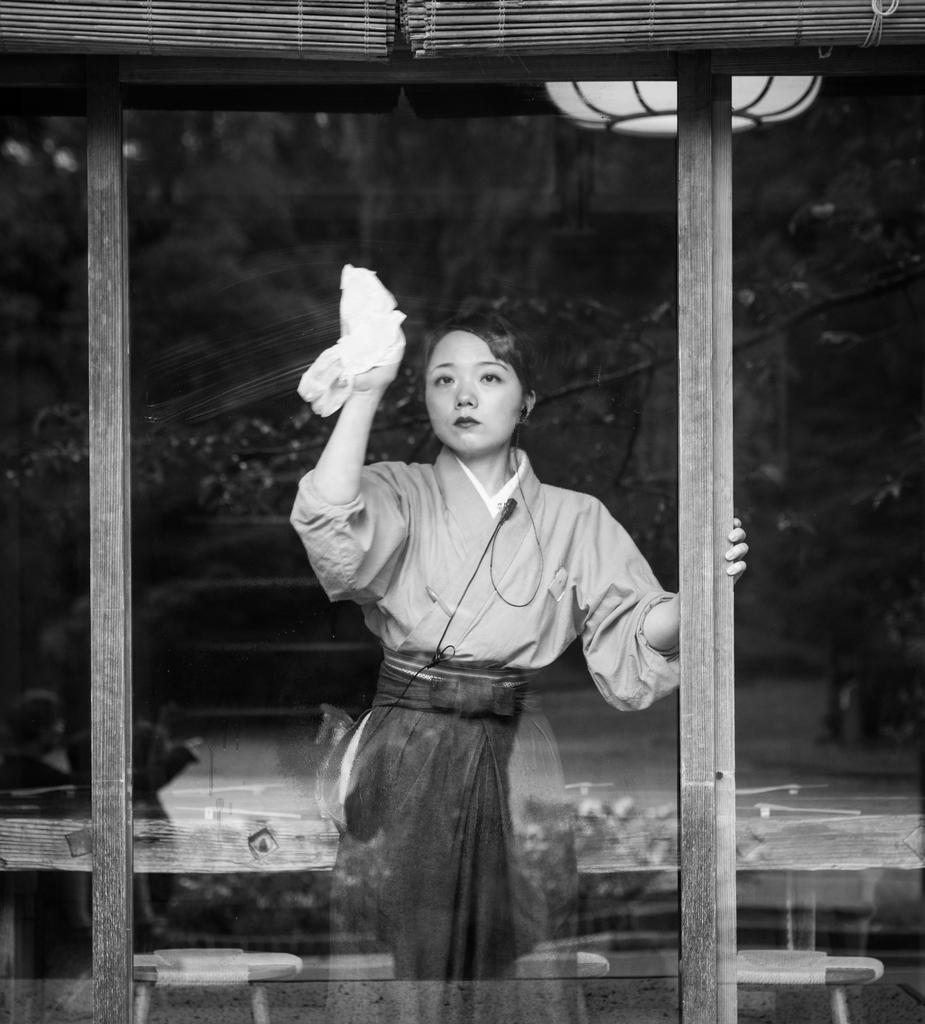Who is the main subject in the image? There is a woman in the image. What is the woman doing in the image? The woman is standing in the image. What is the woman holding in the image? The woman is holding a cloth in the image. What can be seen in the background of the image? There is a tree and light visible in the background of the image. What is the rate at which the jelly is falling in the image? There is no jelly present in the image, so it is not possible to determine a rate at which it might be falling. 